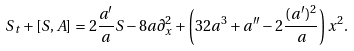<formula> <loc_0><loc_0><loc_500><loc_500>S _ { t } + [ S , A ] = 2 \frac { a ^ { \prime } } { a } S - 8 a \partial _ { x } ^ { 2 } + \left ( 3 2 a ^ { 3 } + a ^ { \prime \prime } - 2 \frac { ( a ^ { \prime } ) ^ { 2 } } { a } \right ) x ^ { 2 } .</formula> 